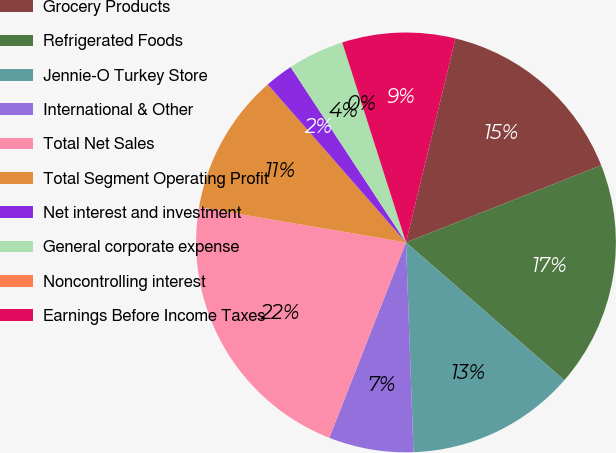Convert chart to OTSL. <chart><loc_0><loc_0><loc_500><loc_500><pie_chart><fcel>Grocery Products<fcel>Refrigerated Foods<fcel>Jennie-O Turkey Store<fcel>International & Other<fcel>Total Net Sales<fcel>Total Segment Operating Profit<fcel>Net interest and investment<fcel>General corporate expense<fcel>Noncontrolling interest<fcel>Earnings Before Income Taxes<nl><fcel>15.22%<fcel>17.39%<fcel>13.04%<fcel>6.52%<fcel>21.74%<fcel>10.87%<fcel>2.18%<fcel>4.35%<fcel>0.0%<fcel>8.7%<nl></chart> 